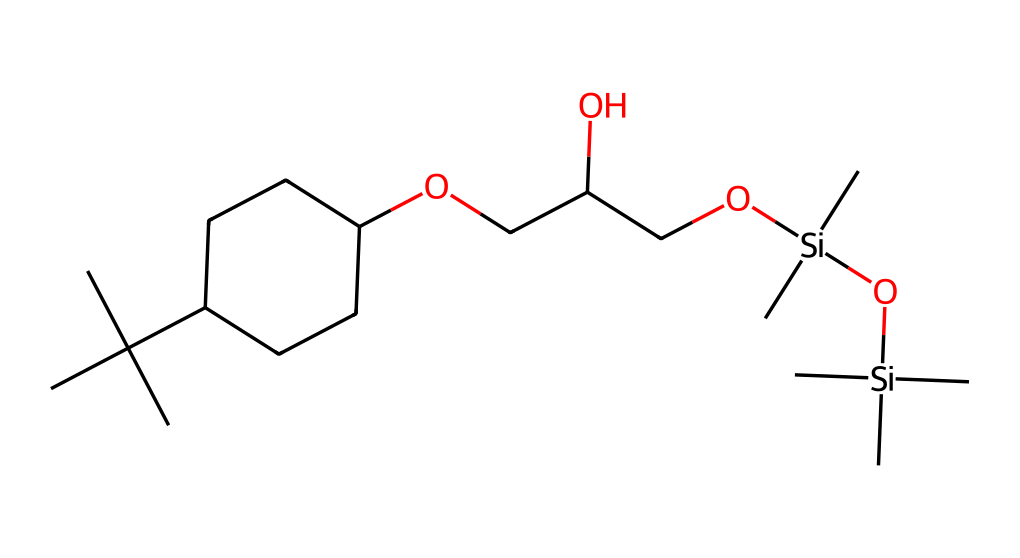What is the main functional group present in this structure? The structure contains an oxygen atom connected to alkyl chains, indicating that it contains an ether (specifically an alkoxy) group. The presence of the ether moiety is signaled by the -O- link in the chain.
Answer: ether How many silicon atoms are in this chemical structure? By analyzing the SMILES representation, the two groups "Si" indicate that there are two silicon atoms present in the molecule.
Answer: two What type of alcohol is indicated by this structure? The presence of the hydroxyl (-OH) group attached to a carbon chain points to the structural features of a primary alcohol in this molecule.
Answer: primary What is the overall molecular formula based on the SMILES provided? Counting all the carbon, hydrogen, oxygen, and silicon atoms in the SMILES representation gives a molecular formula of C16H34O4Si2. The detailed count leads to this formula derived from the components of the structure.
Answer: C16H34O4Si2 How does the branched alkyl group influence the viscosity of the lubricant? The branched alkyl chains improve the lubricant’s viscosity index by reducing the likelihood of packing tightly, leading to lower temperature dependence of viscosity. Therefore, lubricants with branched chains tend to maintain stable viscosity across temperatures.
Answer: stable viscosity What role do the silicone components play in synthetic motor oils for electric vehicles? The silicon components enhance thermal stability and reduce volatility, which are crucial for maintaining performance in electric vehicles where temperatures can vary widely during operation. Therefore, they help in retaining lubricant properties over time.
Answer: thermal stability What is the implication of having multiple -O- linkages in synthetic motor oils for performance? The multiple ether linkages contribute to the oil's oxidative stability and low-temperature flow properties, allowing it to maintain performance under a variety of conditions without thickening. Thus, it aids in maintaining low viscosity at lower temperatures.
Answer: low-temperature performance 